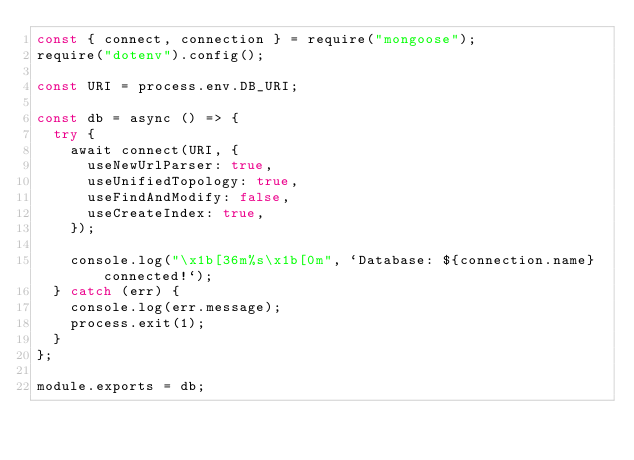Convert code to text. <code><loc_0><loc_0><loc_500><loc_500><_JavaScript_>const { connect, connection } = require("mongoose");
require("dotenv").config();

const URI = process.env.DB_URI;

const db = async () => {
  try {
    await connect(URI, {
      useNewUrlParser: true,
      useUnifiedTopology: true,
      useFindAndModify: false,
      useCreateIndex: true,
    });

    console.log("\x1b[36m%s\x1b[0m", `Database: ${connection.name} connected!`);
  } catch (err) {
    console.log(err.message);
    process.exit(1);
  }
};

module.exports = db;
</code> 